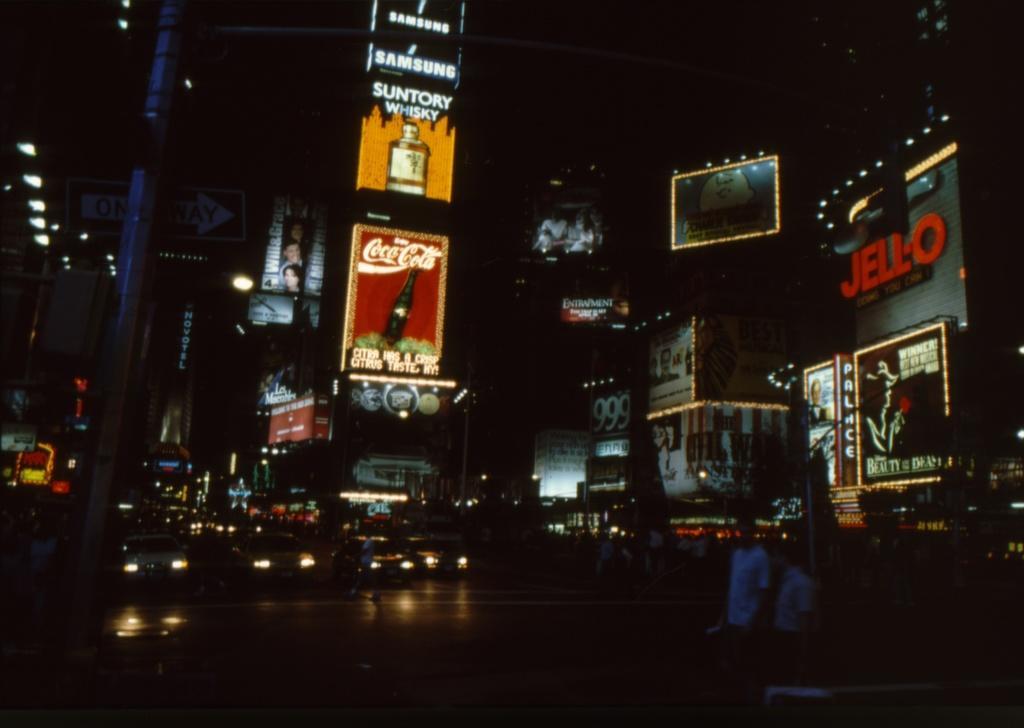How would you summarize this image in a sentence or two? In this picture I can see there are vehicles here on the road and there are buildings in the backdrop and it has some advertisement banners on the buildings. 